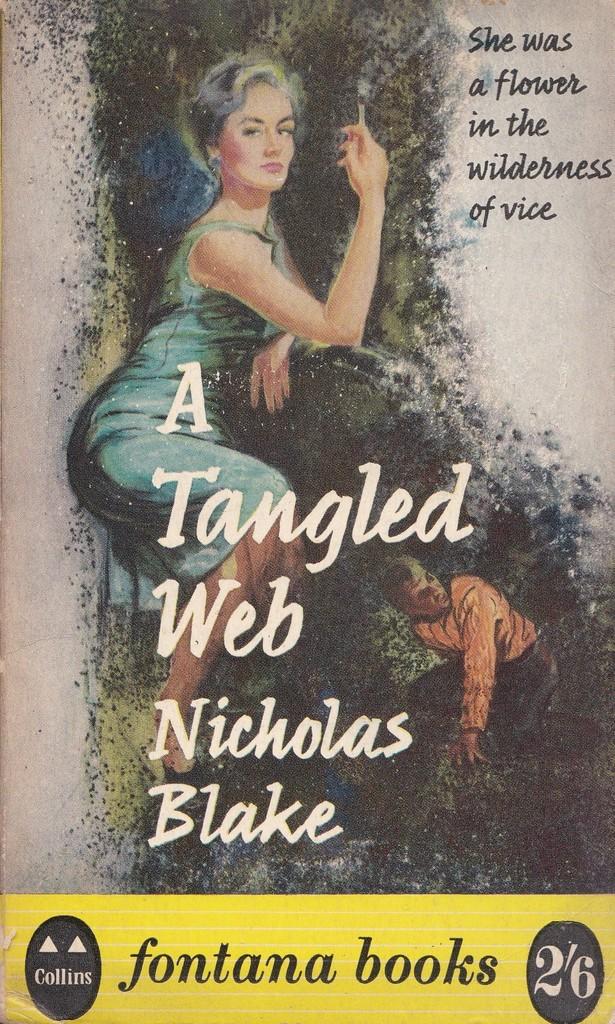What is the book called?
Offer a terse response. A tangled web. Who is the author?
Your response must be concise. Nicholas blake. 